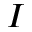Convert formula to latex. <formula><loc_0><loc_0><loc_500><loc_500>I</formula> 